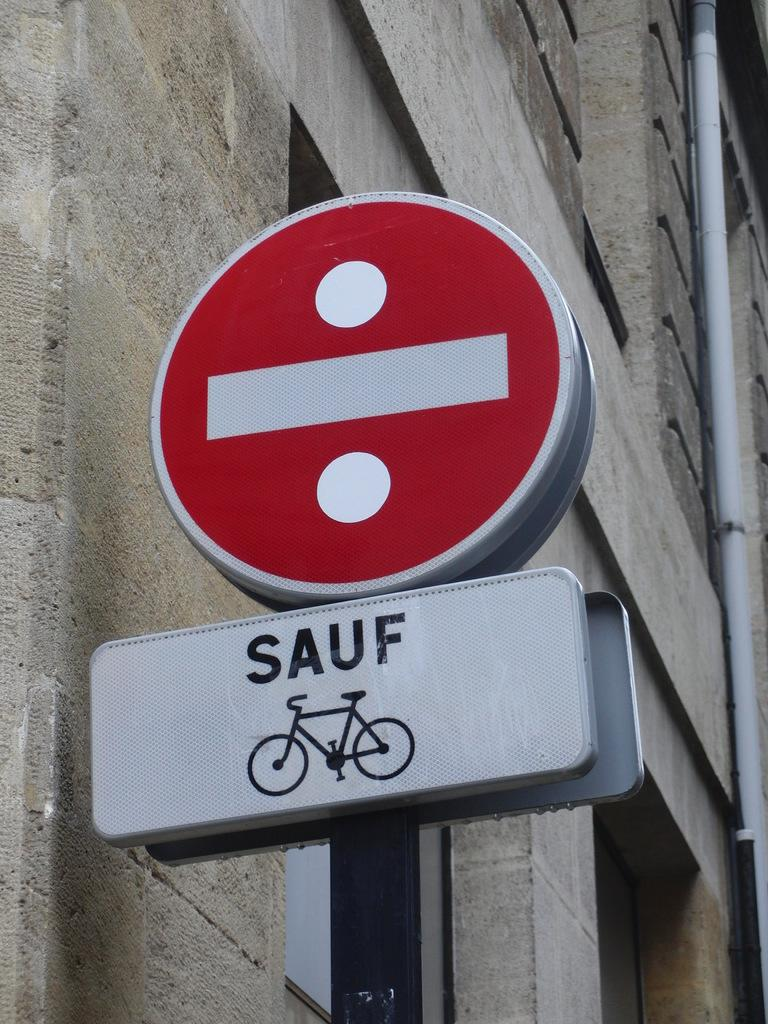<image>
Create a compact narrative representing the image presented. A do not enter sign says "sauf" bicycle meaning they are allowed. 